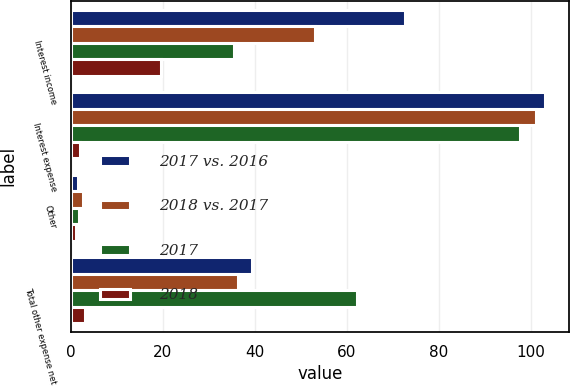Convert chart. <chart><loc_0><loc_0><loc_500><loc_500><stacked_bar_chart><ecel><fcel>Interest income<fcel>Interest expense<fcel>Other<fcel>Total other expense net<nl><fcel>2017 vs. 2016<fcel>72.7<fcel>103.2<fcel>1.6<fcel>39.5<nl><fcel>2018 vs. 2017<fcel>53<fcel>101.2<fcel>2.7<fcel>36.3<nl><fcel>2017<fcel>35.4<fcel>97.7<fcel>1.8<fcel>62.3<nl><fcel>2018<fcel>19.7<fcel>2<fcel>1.1<fcel>3.2<nl></chart> 